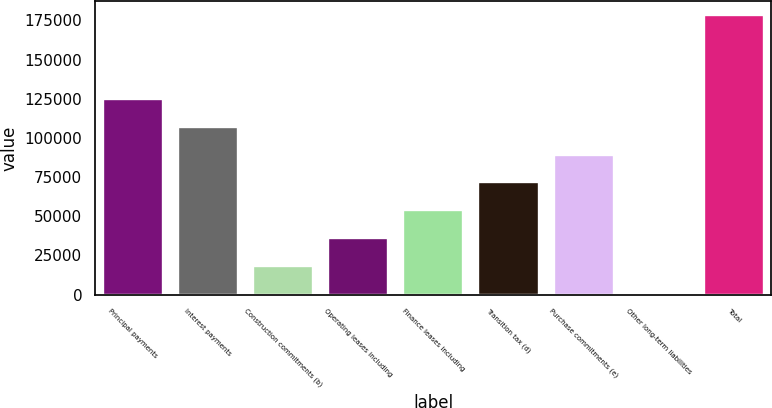Convert chart to OTSL. <chart><loc_0><loc_0><loc_500><loc_500><bar_chart><fcel>Principal payments<fcel>Interest payments<fcel>Construction commitments (b)<fcel>Operating leases including<fcel>Finance leases including<fcel>Transition tax (d)<fcel>Purchase commitments (e)<fcel>Other long-term liabilities<fcel>Total<nl><fcel>124987<fcel>107193<fcel>18219.6<fcel>36014.2<fcel>53808.8<fcel>71603.4<fcel>89398<fcel>425<fcel>178371<nl></chart> 